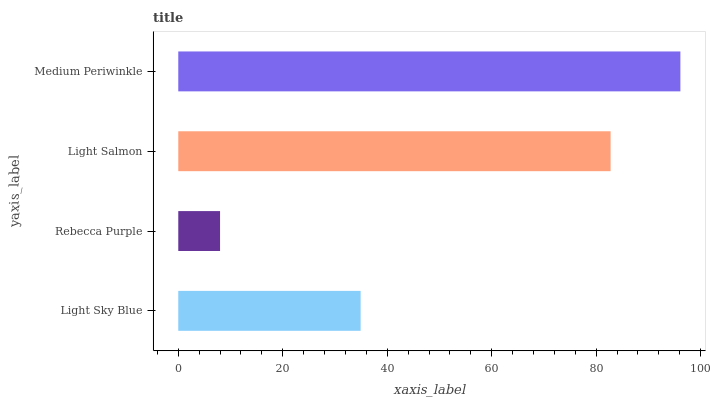Is Rebecca Purple the minimum?
Answer yes or no. Yes. Is Medium Periwinkle the maximum?
Answer yes or no. Yes. Is Light Salmon the minimum?
Answer yes or no. No. Is Light Salmon the maximum?
Answer yes or no. No. Is Light Salmon greater than Rebecca Purple?
Answer yes or no. Yes. Is Rebecca Purple less than Light Salmon?
Answer yes or no. Yes. Is Rebecca Purple greater than Light Salmon?
Answer yes or no. No. Is Light Salmon less than Rebecca Purple?
Answer yes or no. No. Is Light Salmon the high median?
Answer yes or no. Yes. Is Light Sky Blue the low median?
Answer yes or no. Yes. Is Light Sky Blue the high median?
Answer yes or no. No. Is Light Salmon the low median?
Answer yes or no. No. 